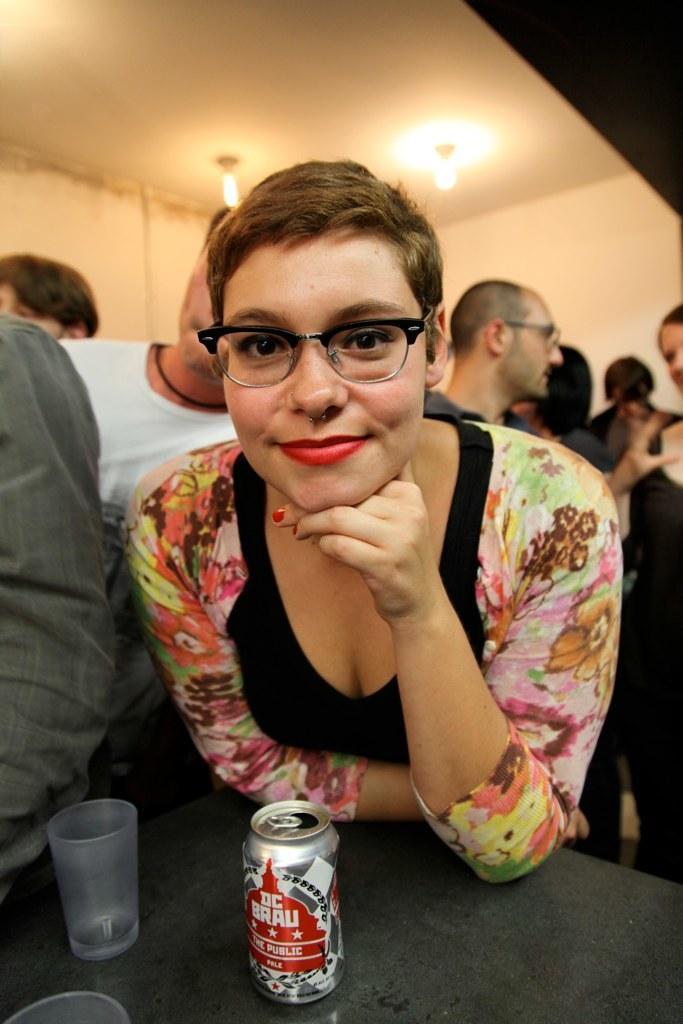Could you give a brief overview of what you see in this image? In this picture we can see a woman with the spectacles. In front of the women there are glasses and tin on the table. Behind the woman there is a group of people. At the top, there are ceiling lights. 